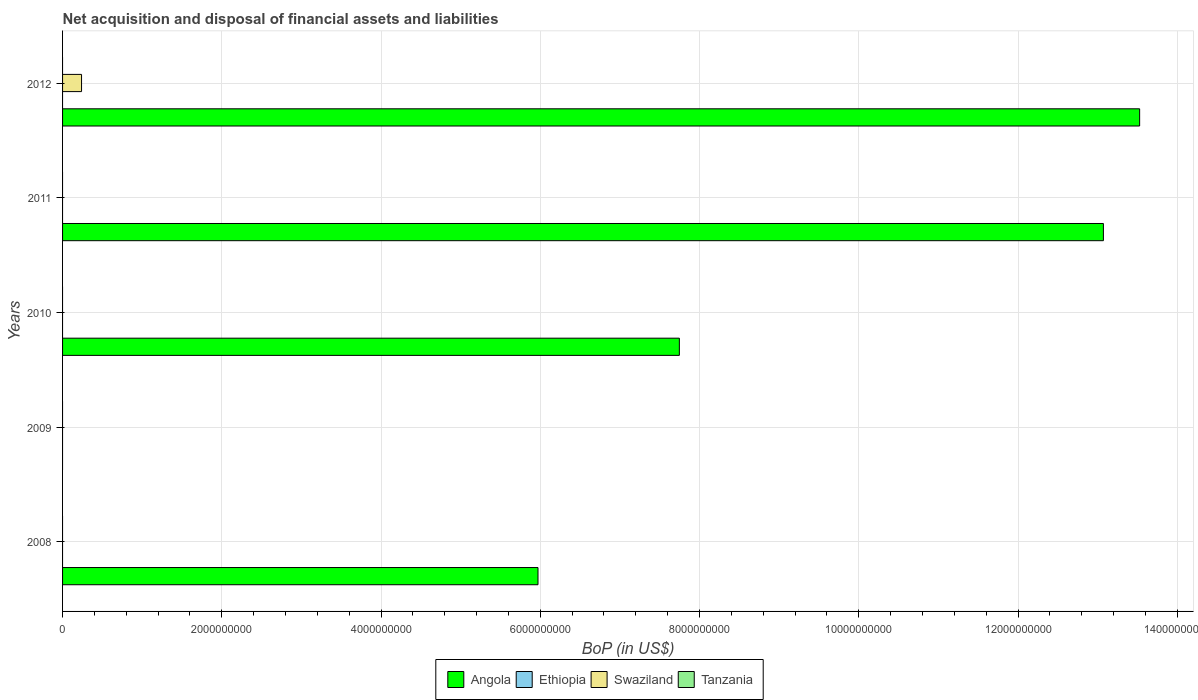How many different coloured bars are there?
Offer a very short reply. 2. Are the number of bars on each tick of the Y-axis equal?
Give a very brief answer. No. In how many cases, is the number of bars for a given year not equal to the number of legend labels?
Provide a short and direct response. 5. What is the Balance of Payments in Ethiopia in 2010?
Ensure brevity in your answer.  0. Across all years, what is the maximum Balance of Payments in Angola?
Make the answer very short. 1.35e+1. Across all years, what is the minimum Balance of Payments in Angola?
Ensure brevity in your answer.  0. What is the difference between the Balance of Payments in Angola in 2008 and that in 2012?
Make the answer very short. -7.56e+09. What is the difference between the Balance of Payments in Ethiopia in 2009 and the Balance of Payments in Angola in 2011?
Provide a short and direct response. -1.31e+1. What is the average Balance of Payments in Ethiopia per year?
Your answer should be very brief. 0. In the year 2012, what is the difference between the Balance of Payments in Angola and Balance of Payments in Swaziland?
Give a very brief answer. 1.33e+1. In how many years, is the Balance of Payments in Tanzania greater than 10000000000 US$?
Offer a very short reply. 0. What is the difference between the highest and the second highest Balance of Payments in Angola?
Give a very brief answer. 4.55e+08. What is the difference between the highest and the lowest Balance of Payments in Swaziland?
Ensure brevity in your answer.  2.38e+08. Is it the case that in every year, the sum of the Balance of Payments in Tanzania and Balance of Payments in Angola is greater than the sum of Balance of Payments in Ethiopia and Balance of Payments in Swaziland?
Offer a terse response. No. Does the graph contain any zero values?
Make the answer very short. Yes. Does the graph contain grids?
Give a very brief answer. Yes. Where does the legend appear in the graph?
Ensure brevity in your answer.  Bottom center. What is the title of the graph?
Your answer should be compact. Net acquisition and disposal of financial assets and liabilities. What is the label or title of the X-axis?
Make the answer very short. BoP (in US$). What is the BoP (in US$) in Angola in 2008?
Offer a very short reply. 5.97e+09. What is the BoP (in US$) in Ethiopia in 2008?
Offer a terse response. 0. What is the BoP (in US$) in Angola in 2009?
Provide a succinct answer. 0. What is the BoP (in US$) in Ethiopia in 2009?
Provide a short and direct response. 0. What is the BoP (in US$) in Angola in 2010?
Give a very brief answer. 7.75e+09. What is the BoP (in US$) in Swaziland in 2010?
Offer a very short reply. 0. What is the BoP (in US$) of Tanzania in 2010?
Your answer should be very brief. 0. What is the BoP (in US$) in Angola in 2011?
Your answer should be very brief. 1.31e+1. What is the BoP (in US$) of Ethiopia in 2011?
Your response must be concise. 0. What is the BoP (in US$) of Tanzania in 2011?
Offer a very short reply. 0. What is the BoP (in US$) of Angola in 2012?
Keep it short and to the point. 1.35e+1. What is the BoP (in US$) of Ethiopia in 2012?
Offer a very short reply. 0. What is the BoP (in US$) in Swaziland in 2012?
Offer a very short reply. 2.38e+08. What is the BoP (in US$) of Tanzania in 2012?
Your answer should be compact. 0. Across all years, what is the maximum BoP (in US$) of Angola?
Provide a short and direct response. 1.35e+1. Across all years, what is the maximum BoP (in US$) in Swaziland?
Provide a succinct answer. 2.38e+08. Across all years, what is the minimum BoP (in US$) in Swaziland?
Keep it short and to the point. 0. What is the total BoP (in US$) of Angola in the graph?
Make the answer very short. 4.03e+1. What is the total BoP (in US$) of Swaziland in the graph?
Keep it short and to the point. 2.38e+08. What is the total BoP (in US$) in Tanzania in the graph?
Offer a terse response. 0. What is the difference between the BoP (in US$) of Angola in 2008 and that in 2010?
Your response must be concise. -1.78e+09. What is the difference between the BoP (in US$) of Angola in 2008 and that in 2011?
Your answer should be compact. -7.10e+09. What is the difference between the BoP (in US$) in Angola in 2008 and that in 2012?
Your response must be concise. -7.56e+09. What is the difference between the BoP (in US$) in Angola in 2010 and that in 2011?
Offer a terse response. -5.33e+09. What is the difference between the BoP (in US$) in Angola in 2010 and that in 2012?
Ensure brevity in your answer.  -5.78e+09. What is the difference between the BoP (in US$) in Angola in 2011 and that in 2012?
Keep it short and to the point. -4.55e+08. What is the difference between the BoP (in US$) in Angola in 2008 and the BoP (in US$) in Swaziland in 2012?
Your answer should be very brief. 5.73e+09. What is the difference between the BoP (in US$) in Angola in 2010 and the BoP (in US$) in Swaziland in 2012?
Offer a terse response. 7.51e+09. What is the difference between the BoP (in US$) in Angola in 2011 and the BoP (in US$) in Swaziland in 2012?
Your answer should be compact. 1.28e+1. What is the average BoP (in US$) in Angola per year?
Give a very brief answer. 8.06e+09. What is the average BoP (in US$) in Ethiopia per year?
Offer a terse response. 0. What is the average BoP (in US$) in Swaziland per year?
Offer a very short reply. 4.77e+07. What is the average BoP (in US$) in Tanzania per year?
Offer a terse response. 0. In the year 2012, what is the difference between the BoP (in US$) of Angola and BoP (in US$) of Swaziland?
Your answer should be very brief. 1.33e+1. What is the ratio of the BoP (in US$) of Angola in 2008 to that in 2010?
Provide a short and direct response. 0.77. What is the ratio of the BoP (in US$) of Angola in 2008 to that in 2011?
Keep it short and to the point. 0.46. What is the ratio of the BoP (in US$) of Angola in 2008 to that in 2012?
Make the answer very short. 0.44. What is the ratio of the BoP (in US$) in Angola in 2010 to that in 2011?
Give a very brief answer. 0.59. What is the ratio of the BoP (in US$) in Angola in 2010 to that in 2012?
Your response must be concise. 0.57. What is the ratio of the BoP (in US$) of Angola in 2011 to that in 2012?
Ensure brevity in your answer.  0.97. What is the difference between the highest and the second highest BoP (in US$) of Angola?
Your answer should be very brief. 4.55e+08. What is the difference between the highest and the lowest BoP (in US$) of Angola?
Provide a short and direct response. 1.35e+1. What is the difference between the highest and the lowest BoP (in US$) in Swaziland?
Offer a very short reply. 2.38e+08. 